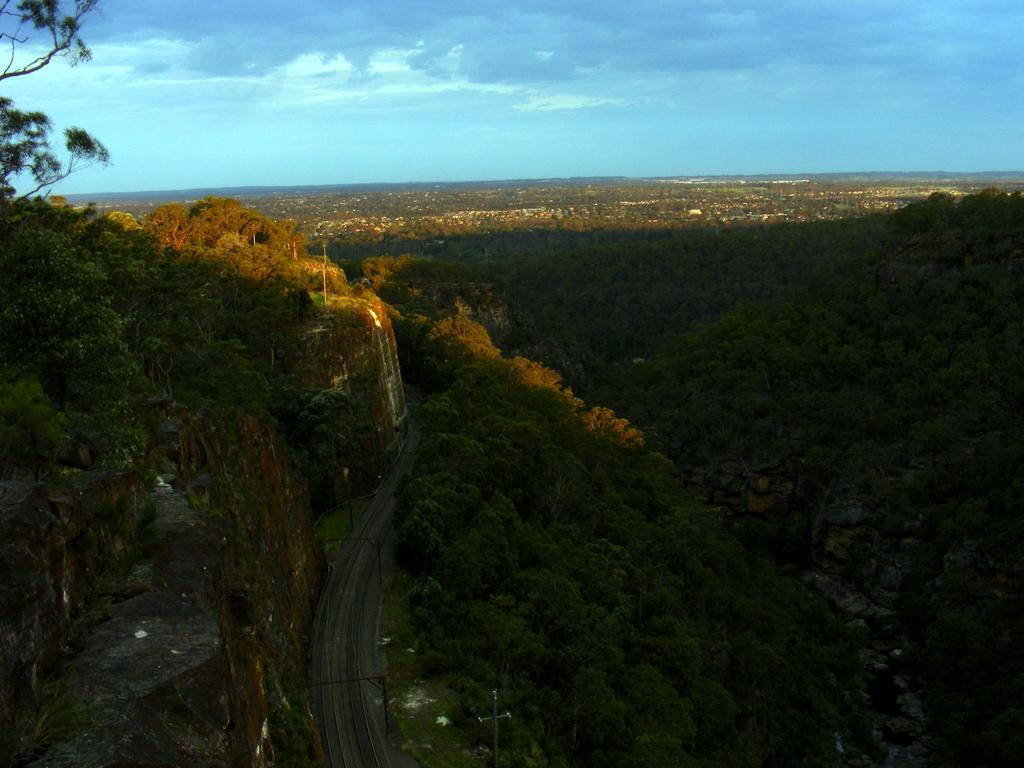What type of landscape is depicted in the image? The image features hills and trees. Can you describe the vegetation in the image? There are trees visible in the image. What is visible in the sky at the top of the image? There are clouds in the sky at the top of the image. What note is the tree playing in the image? There are no musical instruments or notes present in the image; it features hills, trees, and clouds. 